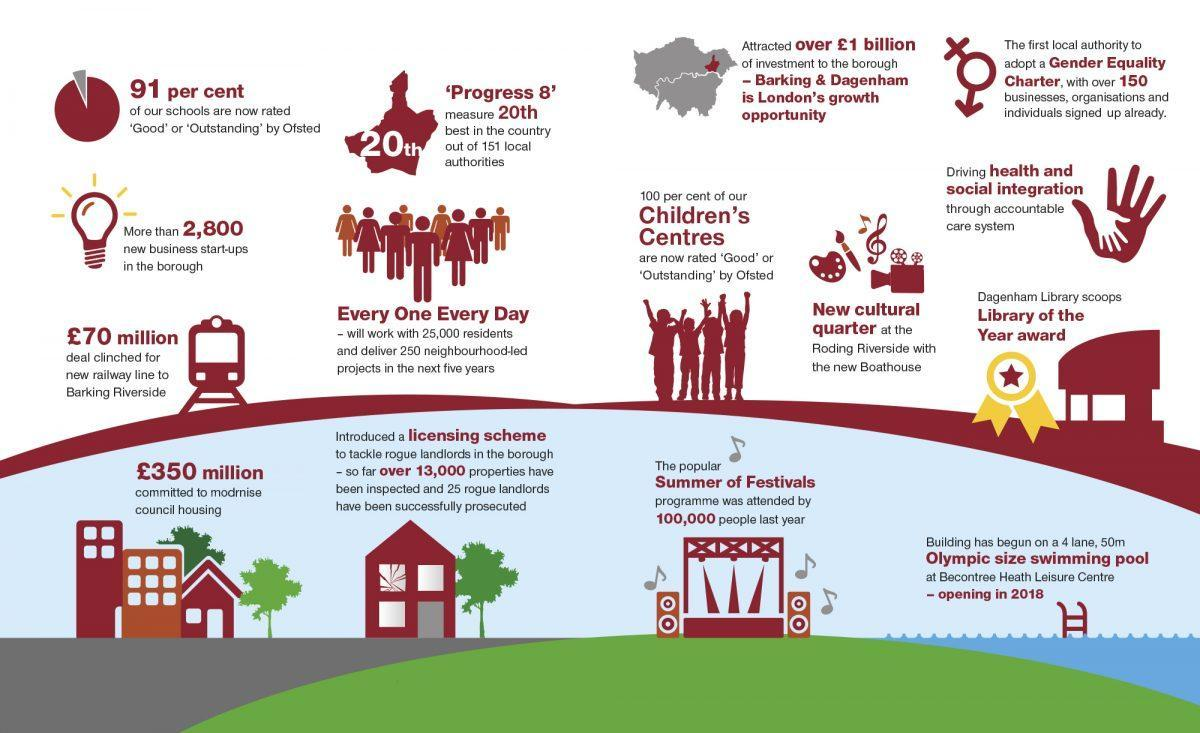What was initiated to tacklet rouge landlords
Answer the question with a short phrase. licensing scheme WHat was the value in pounds of the railway line deal clinched by Barking Riverside 70 million What was the amount in pound committed to modernise council housing 350 million What was the attendance of the summer of festivals 100,000 What % of schools are not rated good or outstanding by Ofsted 9 